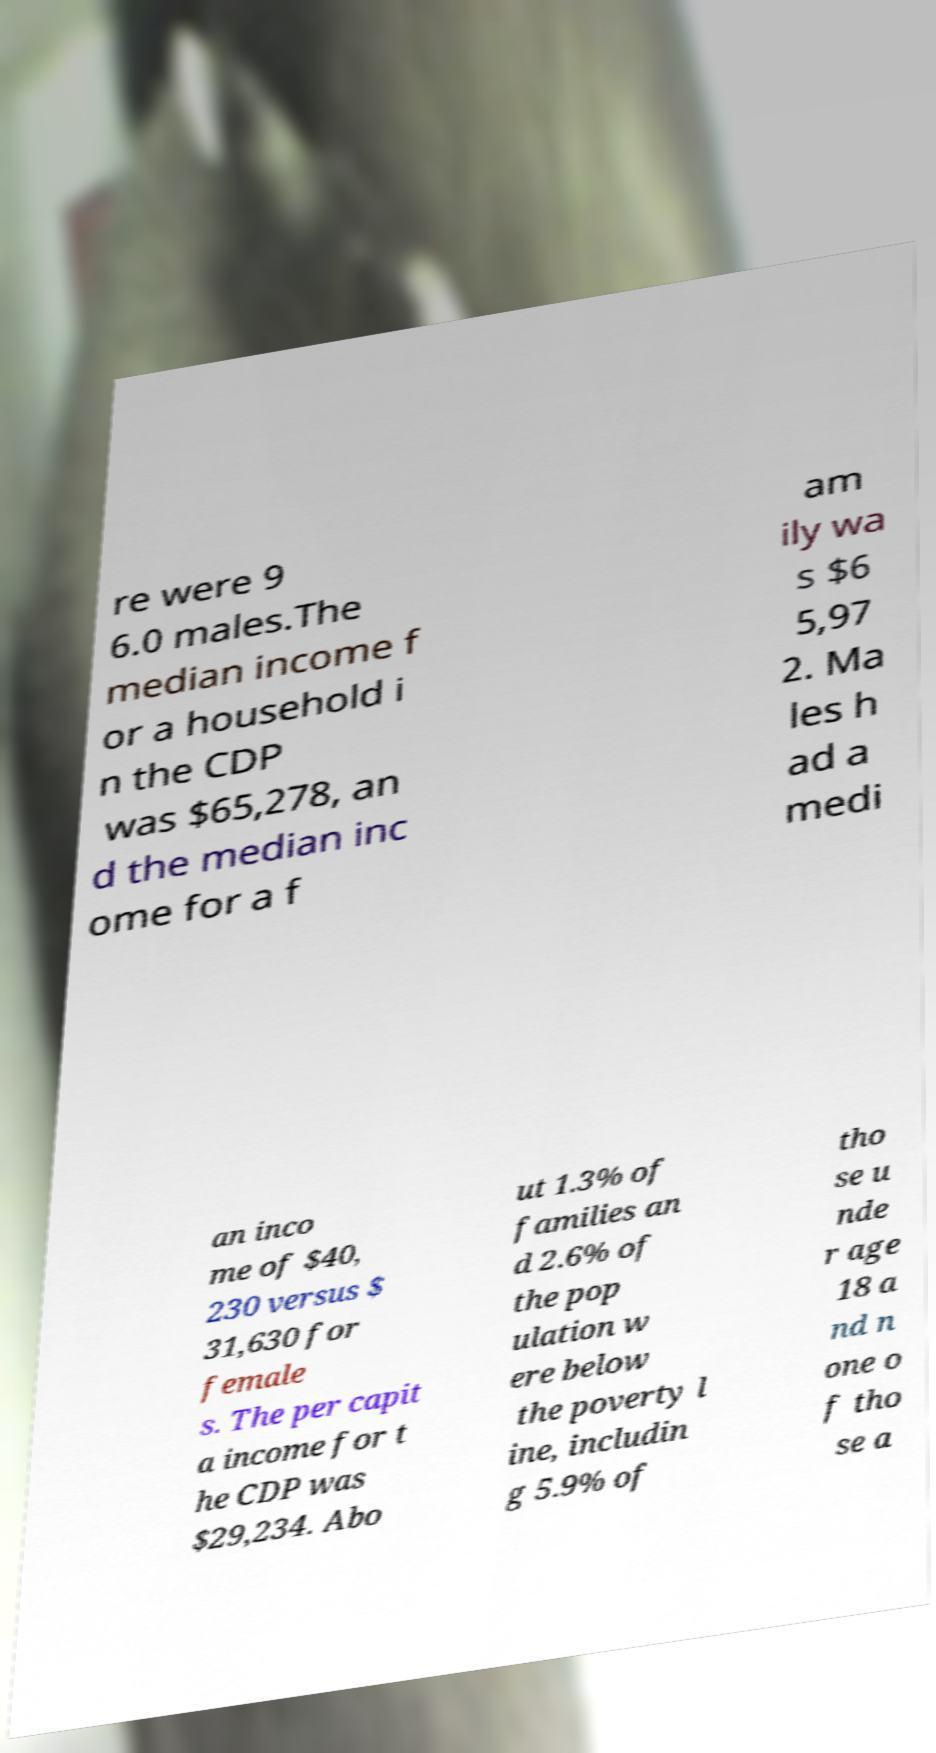Can you accurately transcribe the text from the provided image for me? re were 9 6.0 males.The median income f or a household i n the CDP was $65,278, an d the median inc ome for a f am ily wa s $6 5,97 2. Ma les h ad a medi an inco me of $40, 230 versus $ 31,630 for female s. The per capit a income for t he CDP was $29,234. Abo ut 1.3% of families an d 2.6% of the pop ulation w ere below the poverty l ine, includin g 5.9% of tho se u nde r age 18 a nd n one o f tho se a 